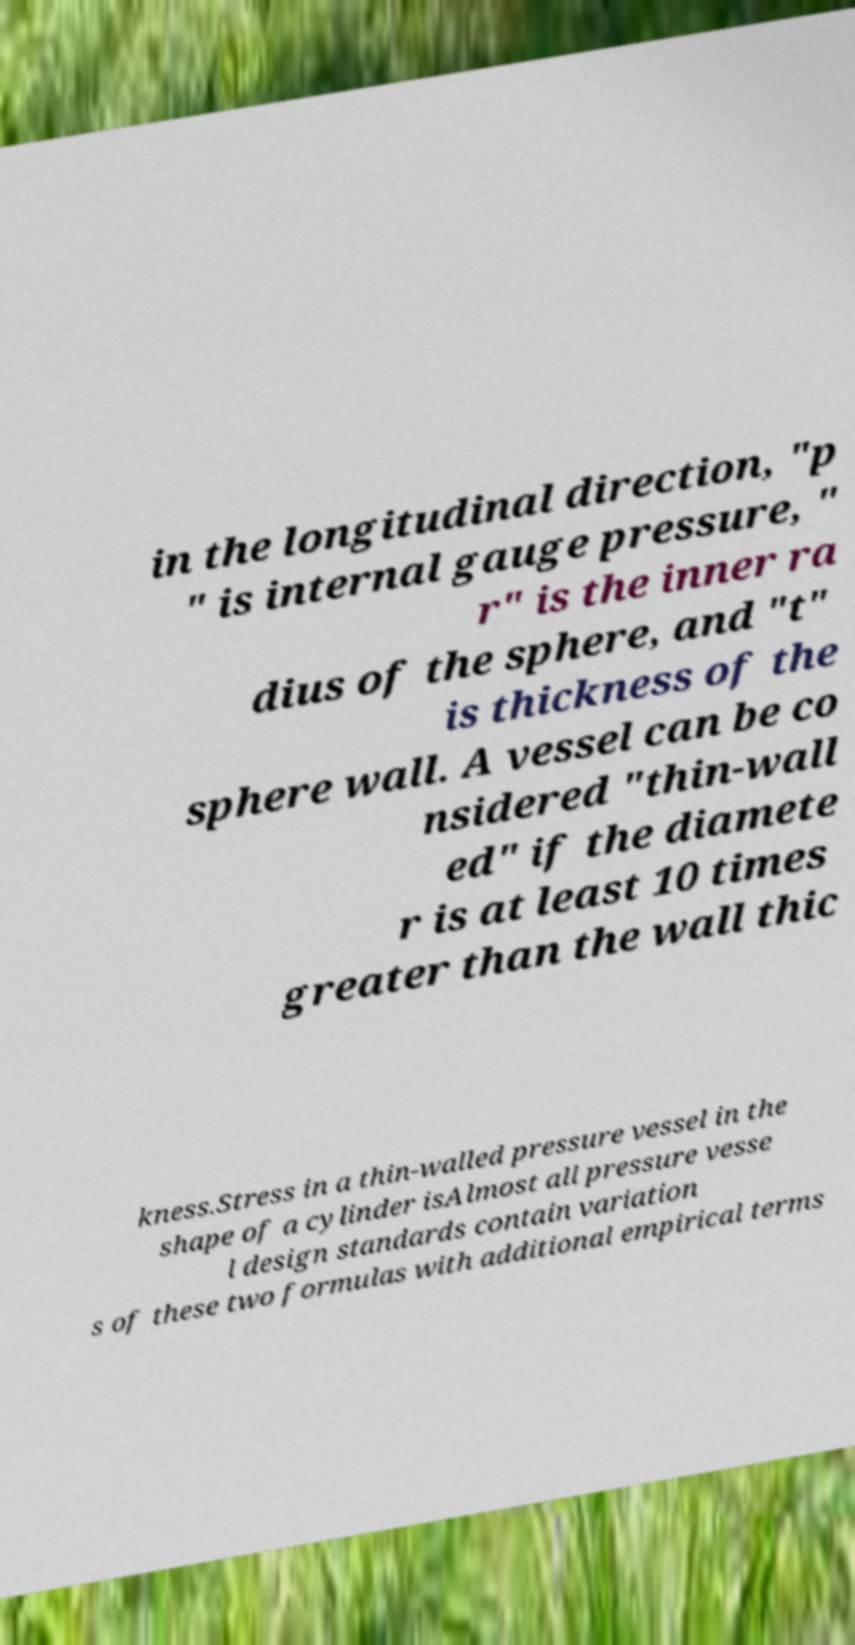Please read and relay the text visible in this image. What does it say? in the longitudinal direction, "p " is internal gauge pressure, " r" is the inner ra dius of the sphere, and "t" is thickness of the sphere wall. A vessel can be co nsidered "thin-wall ed" if the diamete r is at least 10 times greater than the wall thic kness.Stress in a thin-walled pressure vessel in the shape of a cylinder isAlmost all pressure vesse l design standards contain variation s of these two formulas with additional empirical terms 